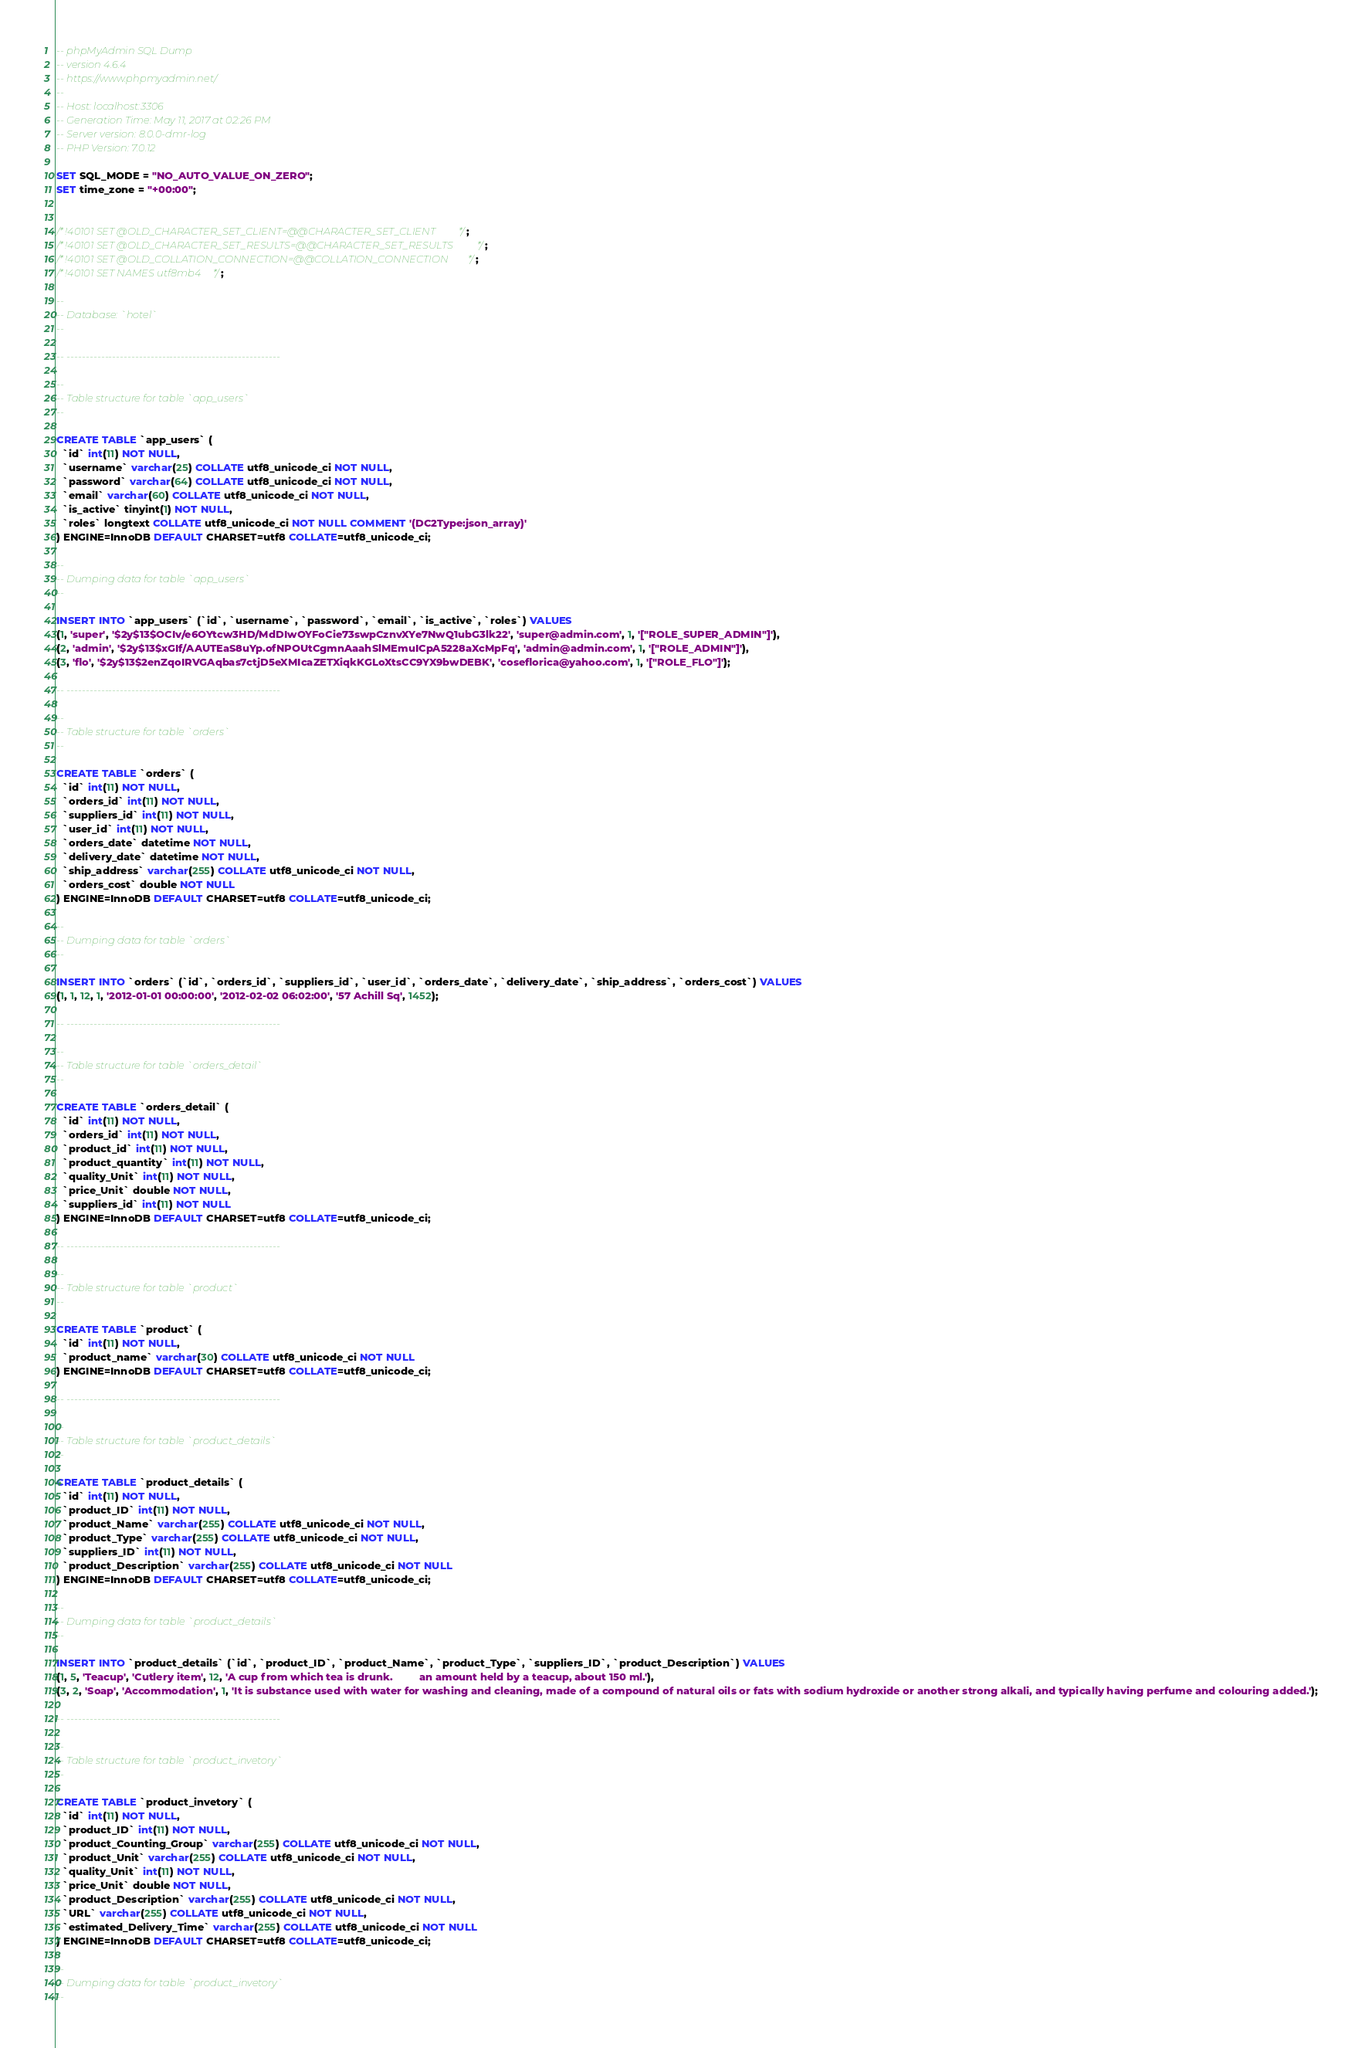<code> <loc_0><loc_0><loc_500><loc_500><_SQL_>-- phpMyAdmin SQL Dump
-- version 4.6.4
-- https://www.phpmyadmin.net/
--
-- Host: localhost:3306
-- Generation Time: May 11, 2017 at 02:26 PM
-- Server version: 8.0.0-dmr-log
-- PHP Version: 7.0.12

SET SQL_MODE = "NO_AUTO_VALUE_ON_ZERO";
SET time_zone = "+00:00";


/*!40101 SET @OLD_CHARACTER_SET_CLIENT=@@CHARACTER_SET_CLIENT */;
/*!40101 SET @OLD_CHARACTER_SET_RESULTS=@@CHARACTER_SET_RESULTS */;
/*!40101 SET @OLD_COLLATION_CONNECTION=@@COLLATION_CONNECTION */;
/*!40101 SET NAMES utf8mb4 */;

--
-- Database: `hotel`
--

-- --------------------------------------------------------

--
-- Table structure for table `app_users`
--

CREATE TABLE `app_users` (
  `id` int(11) NOT NULL,
  `username` varchar(25) COLLATE utf8_unicode_ci NOT NULL,
  `password` varchar(64) COLLATE utf8_unicode_ci NOT NULL,
  `email` varchar(60) COLLATE utf8_unicode_ci NOT NULL,
  `is_active` tinyint(1) NOT NULL,
  `roles` longtext COLLATE utf8_unicode_ci NOT NULL COMMENT '(DC2Type:json_array)'
) ENGINE=InnoDB DEFAULT CHARSET=utf8 COLLATE=utf8_unicode_ci;

--
-- Dumping data for table `app_users`
--

INSERT INTO `app_users` (`id`, `username`, `password`, `email`, `is_active`, `roles`) VALUES
(1, 'super', '$2y$13$OCIv/e6OYtcw3HD/MdDIwOYFoCie73swpCznvXYe7NwQ1ubG3lk22', 'super@admin.com', 1, '["ROLE_SUPER_ADMIN"]'),
(2, 'admin', '$2y$13$xGIf/AAUTEaS8uYp.ofNPOUtCgmnAaahSlMEmuICpA5228aXcMpFq', 'admin@admin.com', 1, '["ROLE_ADMIN"]'),
(3, 'flo', '$2y$13$2enZqoIRVGAqbas7ctjD5eXMIcaZETXiqkKGLoXtsCC9YX9bwDEBK', 'coseflorica@yahoo.com', 1, '["ROLE_FLO"]');

-- --------------------------------------------------------

--
-- Table structure for table `orders`
--

CREATE TABLE `orders` (
  `id` int(11) NOT NULL,
  `orders_id` int(11) NOT NULL,
  `suppliers_id` int(11) NOT NULL,
  `user_id` int(11) NOT NULL,
  `orders_date` datetime NOT NULL,
  `delivery_date` datetime NOT NULL,
  `ship_address` varchar(255) COLLATE utf8_unicode_ci NOT NULL,
  `orders_cost` double NOT NULL
) ENGINE=InnoDB DEFAULT CHARSET=utf8 COLLATE=utf8_unicode_ci;

--
-- Dumping data for table `orders`
--

INSERT INTO `orders` (`id`, `orders_id`, `suppliers_id`, `user_id`, `orders_date`, `delivery_date`, `ship_address`, `orders_cost`) VALUES
(1, 1, 12, 1, '2012-01-01 00:00:00', '2012-02-02 06:02:00', '57 Achill Sq', 1452);

-- --------------------------------------------------------

--
-- Table structure for table `orders_detail`
--

CREATE TABLE `orders_detail` (
  `id` int(11) NOT NULL,
  `orders_id` int(11) NOT NULL,
  `product_id` int(11) NOT NULL,
  `product_quantity` int(11) NOT NULL,
  `quality_Unit` int(11) NOT NULL,
  `price_Unit` double NOT NULL,
  `suppliers_id` int(11) NOT NULL
) ENGINE=InnoDB DEFAULT CHARSET=utf8 COLLATE=utf8_unicode_ci;

-- --------------------------------------------------------

--
-- Table structure for table `product`
--

CREATE TABLE `product` (
  `id` int(11) NOT NULL,
  `product_name` varchar(30) COLLATE utf8_unicode_ci NOT NULL
) ENGINE=InnoDB DEFAULT CHARSET=utf8 COLLATE=utf8_unicode_ci;

-- --------------------------------------------------------

--
-- Table structure for table `product_details`
--

CREATE TABLE `product_details` (
  `id` int(11) NOT NULL,
  `product_ID` int(11) NOT NULL,
  `product_Name` varchar(255) COLLATE utf8_unicode_ci NOT NULL,
  `product_Type` varchar(255) COLLATE utf8_unicode_ci NOT NULL,
  `suppliers_ID` int(11) NOT NULL,
  `product_Description` varchar(255) COLLATE utf8_unicode_ci NOT NULL
) ENGINE=InnoDB DEFAULT CHARSET=utf8 COLLATE=utf8_unicode_ci;

--
-- Dumping data for table `product_details`
--

INSERT INTO `product_details` (`id`, `product_ID`, `product_Name`, `product_Type`, `suppliers_ID`, `product_Description`) VALUES
(1, 5, 'Teacup', 'Cutlery item', 12, 'A cup from which tea is drunk.         an amount held by a teacup, about 150 ml.'),
(3, 2, 'Soap', 'Accommodation', 1, 'It is substance used with water for washing and cleaning, made of a compound of natural oils or fats with sodium hydroxide or another strong alkali, and typically having perfume and colouring added.');

-- --------------------------------------------------------

--
-- Table structure for table `product_invetory`
--

CREATE TABLE `product_invetory` (
  `id` int(11) NOT NULL,
  `product_ID` int(11) NOT NULL,
  `product_Counting_Group` varchar(255) COLLATE utf8_unicode_ci NOT NULL,
  `product_Unit` varchar(255) COLLATE utf8_unicode_ci NOT NULL,
  `quality_Unit` int(11) NOT NULL,
  `price_Unit` double NOT NULL,
  `product_Description` varchar(255) COLLATE utf8_unicode_ci NOT NULL,
  `URL` varchar(255) COLLATE utf8_unicode_ci NOT NULL,
  `estimated_Delivery_Time` varchar(255) COLLATE utf8_unicode_ci NOT NULL
) ENGINE=InnoDB DEFAULT CHARSET=utf8 COLLATE=utf8_unicode_ci;

--
-- Dumping data for table `product_invetory`
--
</code> 